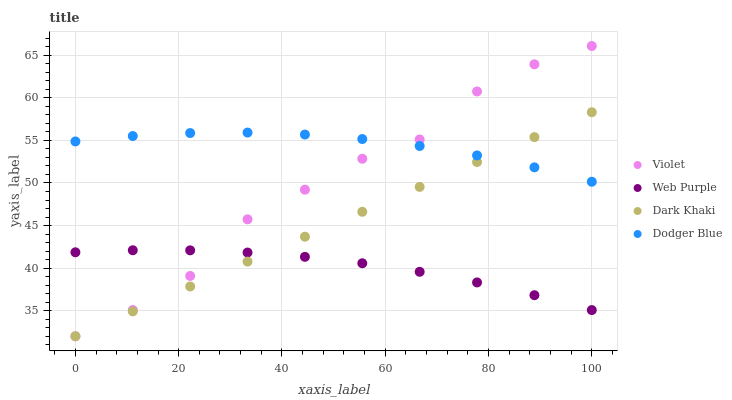Does Web Purple have the minimum area under the curve?
Answer yes or no. Yes. Does Dodger Blue have the maximum area under the curve?
Answer yes or no. Yes. Does Dodger Blue have the minimum area under the curve?
Answer yes or no. No. Does Web Purple have the maximum area under the curve?
Answer yes or no. No. Is Dark Khaki the smoothest?
Answer yes or no. Yes. Is Violet the roughest?
Answer yes or no. Yes. Is Web Purple the smoothest?
Answer yes or no. No. Is Web Purple the roughest?
Answer yes or no. No. Does Dark Khaki have the lowest value?
Answer yes or no. Yes. Does Web Purple have the lowest value?
Answer yes or no. No. Does Violet have the highest value?
Answer yes or no. Yes. Does Dodger Blue have the highest value?
Answer yes or no. No. Is Web Purple less than Dodger Blue?
Answer yes or no. Yes. Is Dodger Blue greater than Web Purple?
Answer yes or no. Yes. Does Dark Khaki intersect Dodger Blue?
Answer yes or no. Yes. Is Dark Khaki less than Dodger Blue?
Answer yes or no. No. Is Dark Khaki greater than Dodger Blue?
Answer yes or no. No. Does Web Purple intersect Dodger Blue?
Answer yes or no. No. 